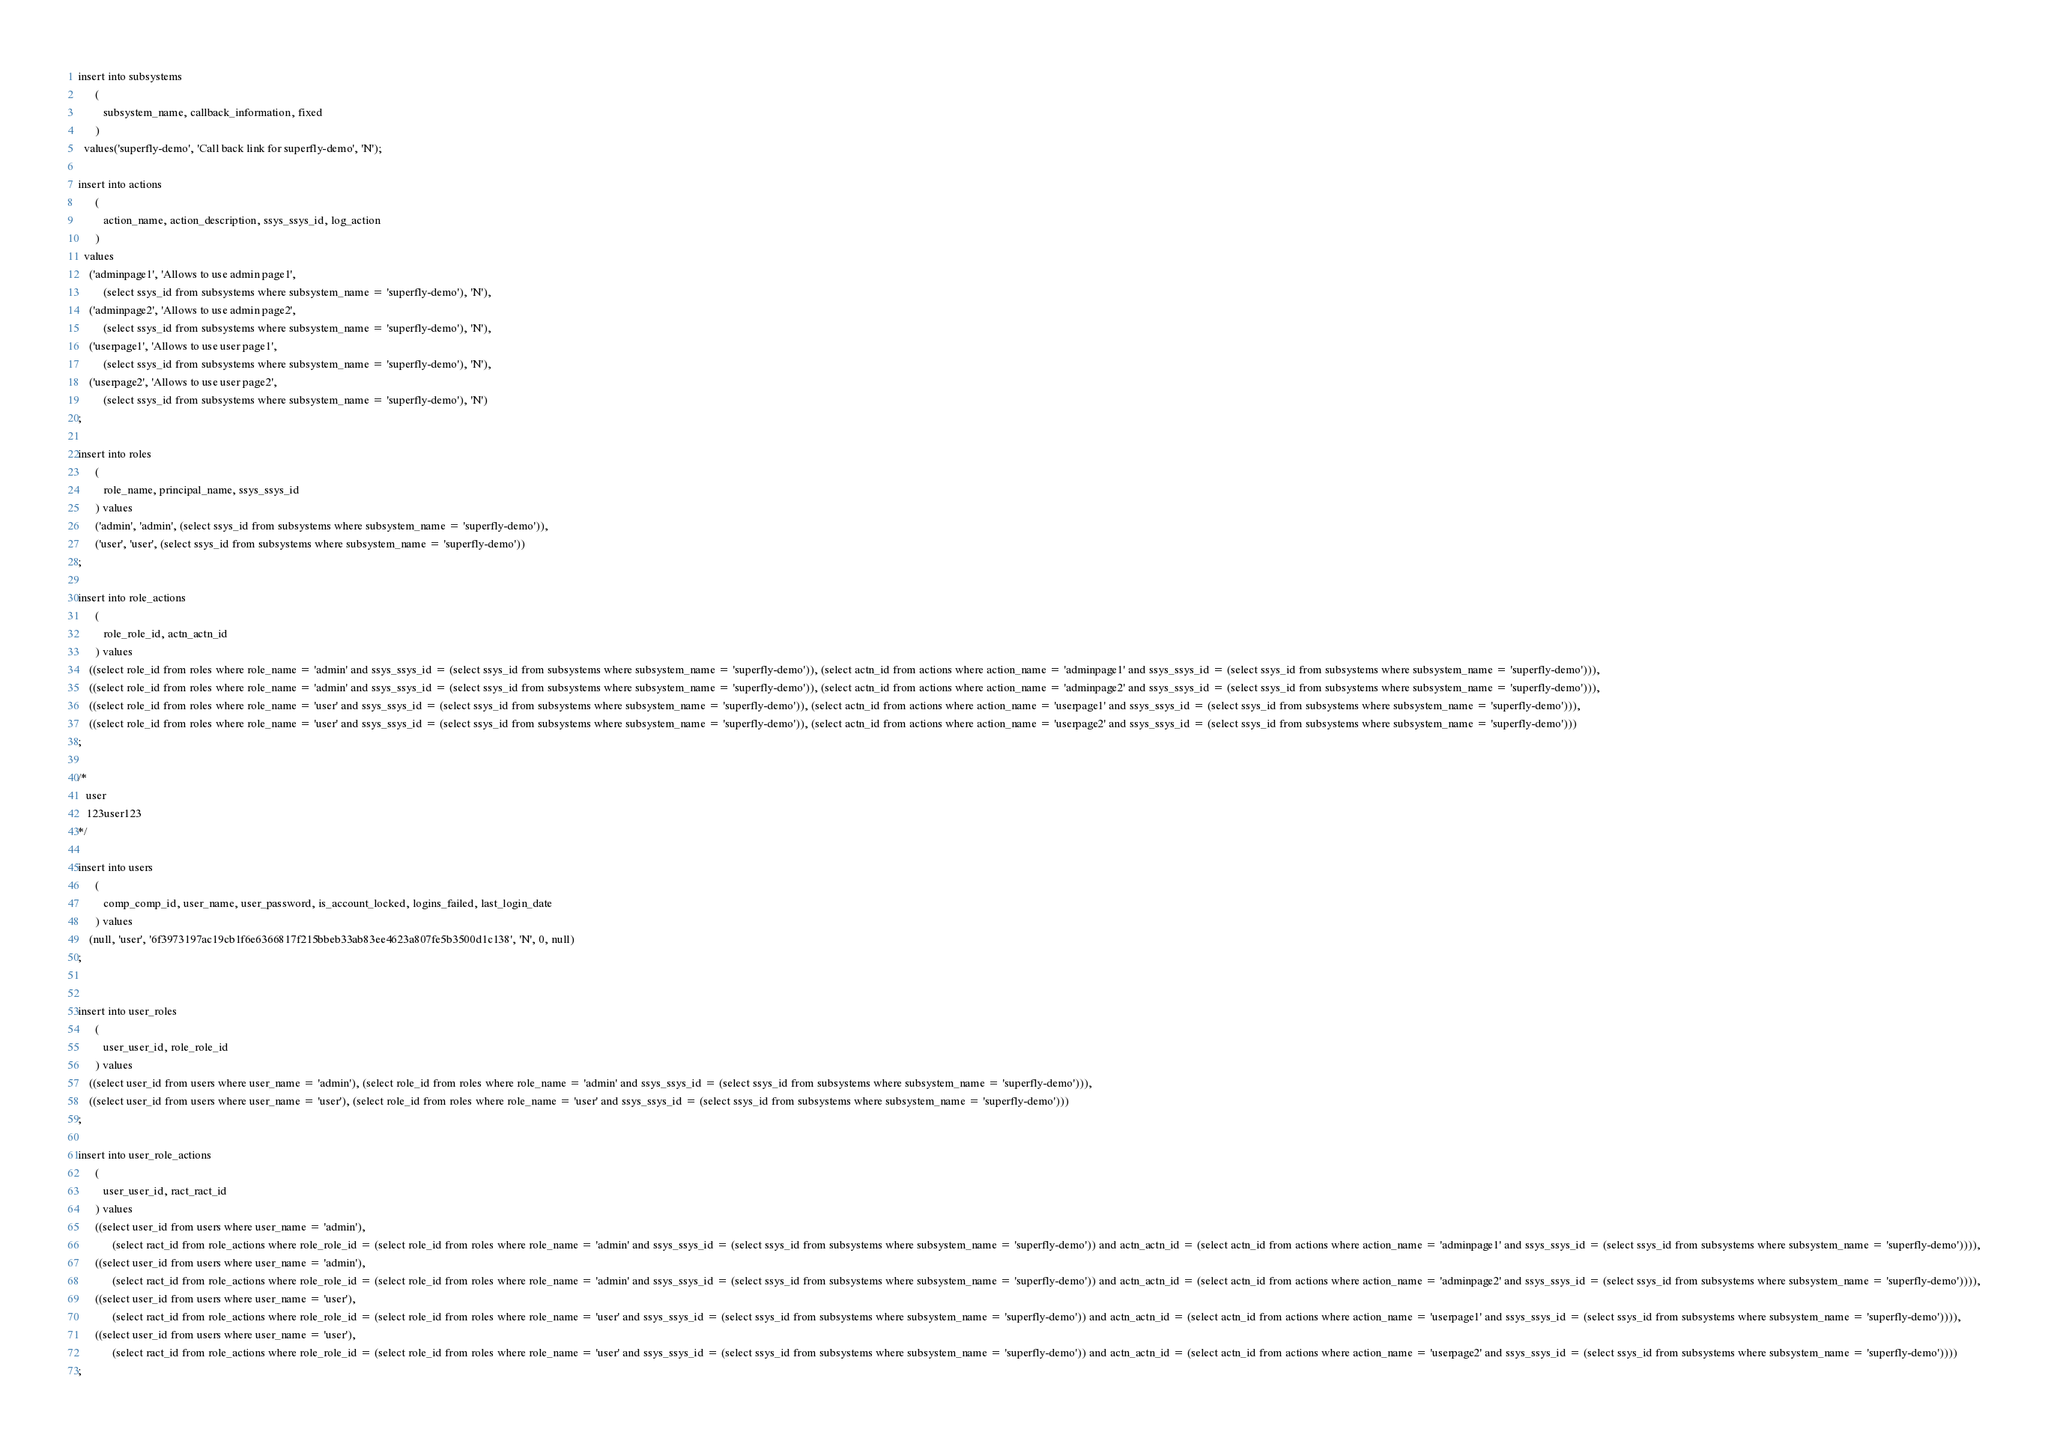Convert code to text. <code><loc_0><loc_0><loc_500><loc_500><_SQL_>insert into subsystems
      (
         subsystem_name, callback_information, fixed
      )
  values('superfly-demo', 'Call back link for superfly-demo', 'N');

insert into actions
      (
         action_name, action_description, ssys_ssys_id, log_action
      )
  values
    ('adminpage1', 'Allows to use admin page1',
         (select ssys_id from subsystems where subsystem_name = 'superfly-demo'), 'N'),
    ('adminpage2', 'Allows to use admin page2',
         (select ssys_id from subsystems where subsystem_name = 'superfly-demo'), 'N'),
    ('userpage1', 'Allows to use user page1',
         (select ssys_id from subsystems where subsystem_name = 'superfly-demo'), 'N'),
    ('userpage2', 'Allows to use user page2',
         (select ssys_id from subsystems where subsystem_name = 'superfly-demo'), 'N')
;

insert into roles
      (
         role_name, principal_name, ssys_ssys_id
      ) values
      ('admin', 'admin', (select ssys_id from subsystems where subsystem_name = 'superfly-demo')),
      ('user', 'user', (select ssys_id from subsystems where subsystem_name = 'superfly-demo'))
;

insert into role_actions
      (
         role_role_id, actn_actn_id
      ) values
    ((select role_id from roles where role_name = 'admin' and ssys_ssys_id = (select ssys_id from subsystems where subsystem_name = 'superfly-demo')), (select actn_id from actions where action_name = 'adminpage1' and ssys_ssys_id = (select ssys_id from subsystems where subsystem_name = 'superfly-demo'))),
    ((select role_id from roles where role_name = 'admin' and ssys_ssys_id = (select ssys_id from subsystems where subsystem_name = 'superfly-demo')), (select actn_id from actions where action_name = 'adminpage2' and ssys_ssys_id = (select ssys_id from subsystems where subsystem_name = 'superfly-demo'))),
    ((select role_id from roles where role_name = 'user' and ssys_ssys_id = (select ssys_id from subsystems where subsystem_name = 'superfly-demo')), (select actn_id from actions where action_name = 'userpage1' and ssys_ssys_id = (select ssys_id from subsystems where subsystem_name = 'superfly-demo'))),
    ((select role_id from roles where role_name = 'user' and ssys_ssys_id = (select ssys_id from subsystems where subsystem_name = 'superfly-demo')), (select actn_id from actions where action_name = 'userpage2' and ssys_ssys_id = (select ssys_id from subsystems where subsystem_name = 'superfly-demo')))
;

/*
   user 
   123user123
*/

insert into users
      (
         comp_comp_id, user_name, user_password, is_account_locked, logins_failed, last_login_date
      ) values 
    (null, 'user', '6f3973197ac19cb1f6e6366817f215bbeb33ab83ee4623a807fe5b3500d1c138', 'N', 0, null)
;


insert into user_roles
      (
         user_user_id, role_role_id
      ) values
    ((select user_id from users where user_name = 'admin'), (select role_id from roles where role_name = 'admin' and ssys_ssys_id = (select ssys_id from subsystems where subsystem_name = 'superfly-demo'))),
    ((select user_id from users where user_name = 'user'), (select role_id from roles where role_name = 'user' and ssys_ssys_id = (select ssys_id from subsystems where subsystem_name = 'superfly-demo')))
;

insert into user_role_actions
      (
         user_user_id, ract_ract_id
      ) values
      ((select user_id from users where user_name = 'admin'),
            (select ract_id from role_actions where role_role_id = (select role_id from roles where role_name = 'admin' and ssys_ssys_id = (select ssys_id from subsystems where subsystem_name = 'superfly-demo')) and actn_actn_id = (select actn_id from actions where action_name = 'adminpage1' and ssys_ssys_id = (select ssys_id from subsystems where subsystem_name = 'superfly-demo')))),
      ((select user_id from users where user_name = 'admin'),
            (select ract_id from role_actions where role_role_id = (select role_id from roles where role_name = 'admin' and ssys_ssys_id = (select ssys_id from subsystems where subsystem_name = 'superfly-demo')) and actn_actn_id = (select actn_id from actions where action_name = 'adminpage2' and ssys_ssys_id = (select ssys_id from subsystems where subsystem_name = 'superfly-demo')))),
      ((select user_id from users where user_name = 'user'),
            (select ract_id from role_actions where role_role_id = (select role_id from roles where role_name = 'user' and ssys_ssys_id = (select ssys_id from subsystems where subsystem_name = 'superfly-demo')) and actn_actn_id = (select actn_id from actions where action_name = 'userpage1' and ssys_ssys_id = (select ssys_id from subsystems where subsystem_name = 'superfly-demo')))),
      ((select user_id from users where user_name = 'user'),
            (select ract_id from role_actions where role_role_id = (select role_id from roles where role_name = 'user' and ssys_ssys_id = (select ssys_id from subsystems where subsystem_name = 'superfly-demo')) and actn_actn_id = (select actn_id from actions where action_name = 'userpage2' and ssys_ssys_id = (select ssys_id from subsystems where subsystem_name = 'superfly-demo'))))
;
</code> 